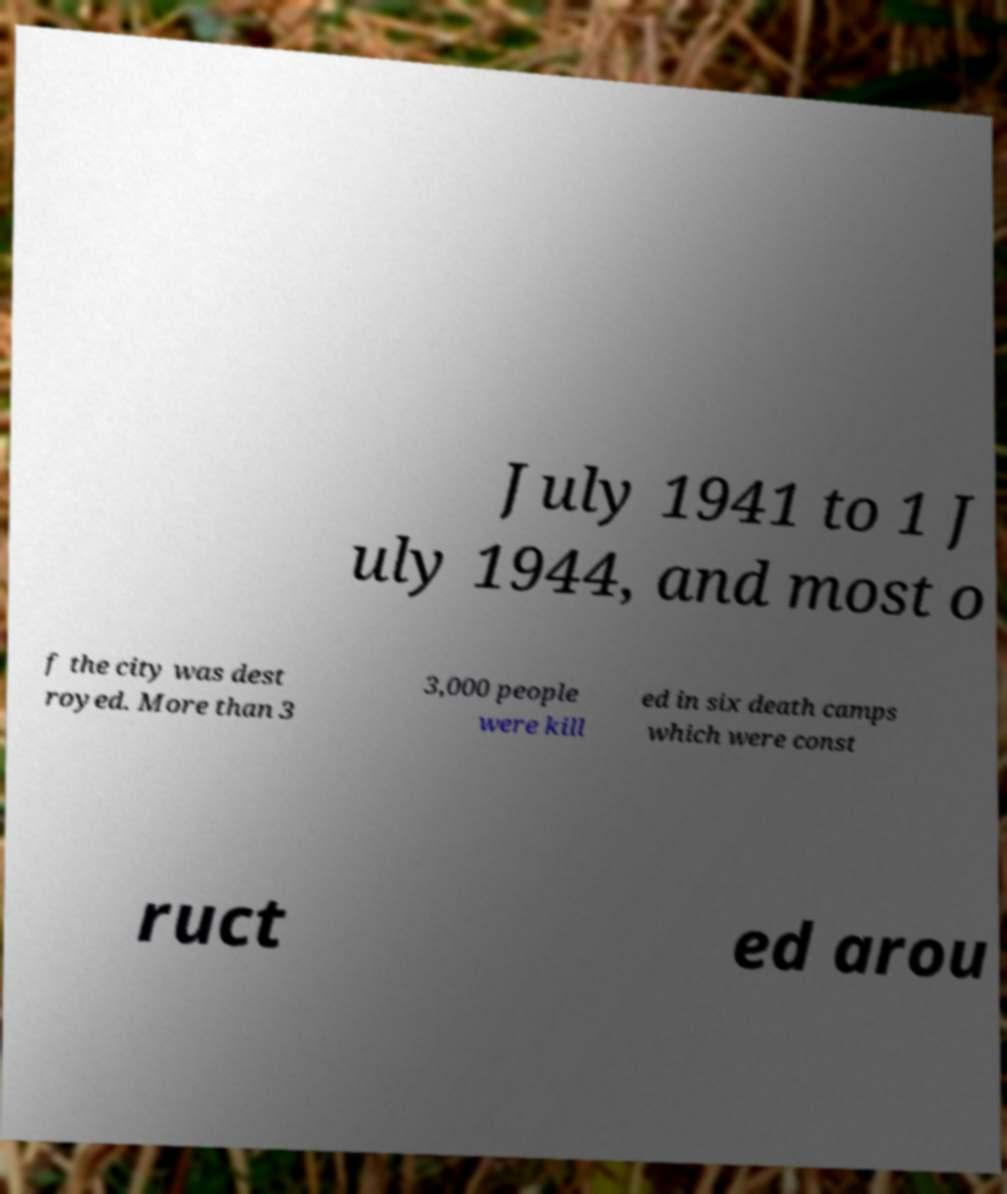What messages or text are displayed in this image? I need them in a readable, typed format. July 1941 to 1 J uly 1944, and most o f the city was dest royed. More than 3 3,000 people were kill ed in six death camps which were const ruct ed arou 